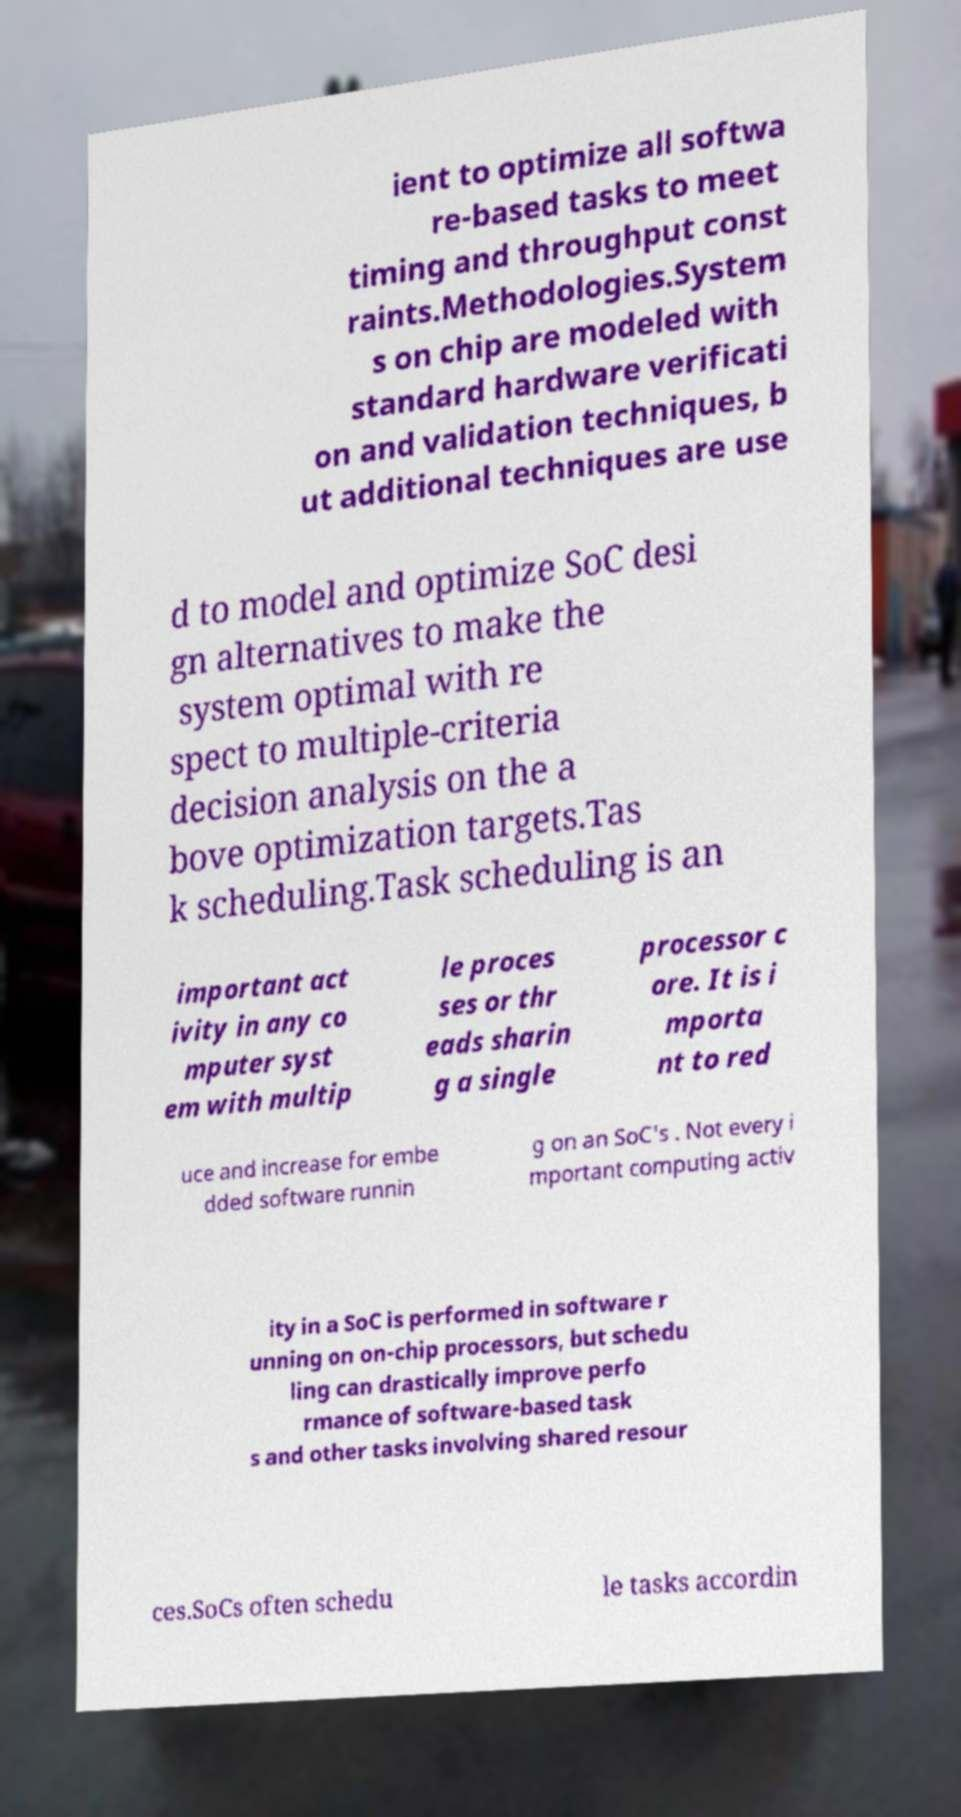Please identify and transcribe the text found in this image. ient to optimize all softwa re-based tasks to meet timing and throughput const raints.Methodologies.System s on chip are modeled with standard hardware verificati on and validation techniques, b ut additional techniques are use d to model and optimize SoC desi gn alternatives to make the system optimal with re spect to multiple-criteria decision analysis on the a bove optimization targets.Tas k scheduling.Task scheduling is an important act ivity in any co mputer syst em with multip le proces ses or thr eads sharin g a single processor c ore. It is i mporta nt to red uce and increase for embe dded software runnin g on an SoC's . Not every i mportant computing activ ity in a SoC is performed in software r unning on on-chip processors, but schedu ling can drastically improve perfo rmance of software-based task s and other tasks involving shared resour ces.SoCs often schedu le tasks accordin 